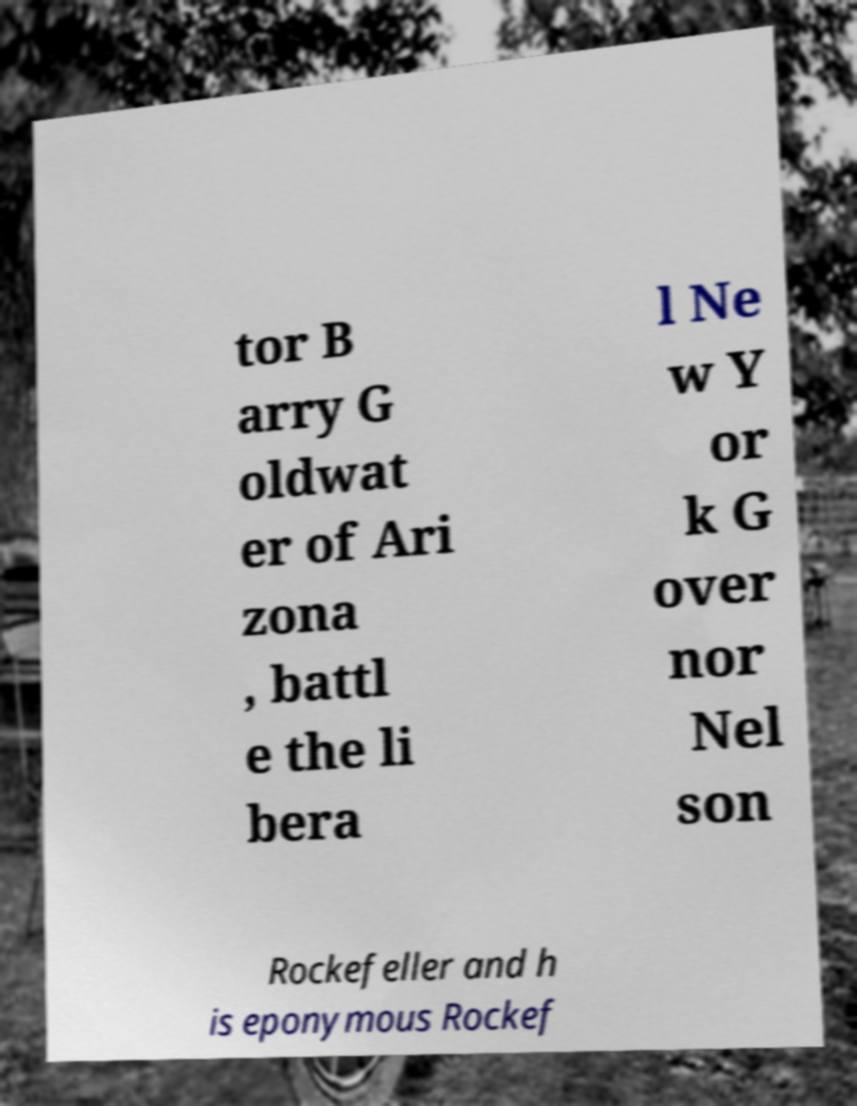Please read and relay the text visible in this image. What does it say? tor B arry G oldwat er of Ari zona , battl e the li bera l Ne w Y or k G over nor Nel son Rockefeller and h is eponymous Rockef 